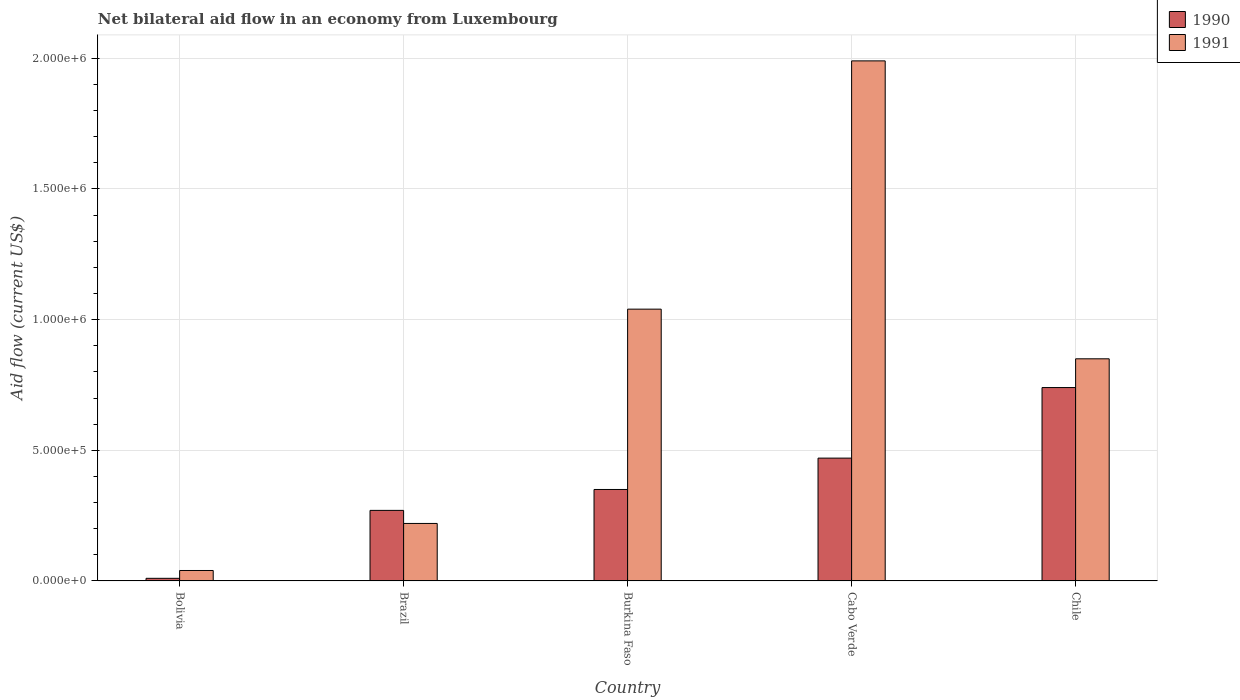How many different coloured bars are there?
Give a very brief answer. 2. How many bars are there on the 5th tick from the left?
Your answer should be compact. 2. In how many cases, is the number of bars for a given country not equal to the number of legend labels?
Your answer should be very brief. 0. What is the net bilateral aid flow in 1991 in Cabo Verde?
Offer a very short reply. 1.99e+06. Across all countries, what is the maximum net bilateral aid flow in 1991?
Offer a very short reply. 1.99e+06. In which country was the net bilateral aid flow in 1991 minimum?
Keep it short and to the point. Bolivia. What is the total net bilateral aid flow in 1991 in the graph?
Provide a succinct answer. 4.14e+06. What is the difference between the net bilateral aid flow in 1991 in Burkina Faso and the net bilateral aid flow in 1990 in Brazil?
Provide a short and direct response. 7.70e+05. What is the average net bilateral aid flow in 1991 per country?
Make the answer very short. 8.28e+05. What is the difference between the net bilateral aid flow of/in 1990 and net bilateral aid flow of/in 1991 in Bolivia?
Your answer should be compact. -3.00e+04. In how many countries, is the net bilateral aid flow in 1991 greater than 100000 US$?
Provide a short and direct response. 4. What is the ratio of the net bilateral aid flow in 1991 in Bolivia to that in Brazil?
Offer a terse response. 0.18. Is the difference between the net bilateral aid flow in 1990 in Bolivia and Cabo Verde greater than the difference between the net bilateral aid flow in 1991 in Bolivia and Cabo Verde?
Offer a very short reply. Yes. What is the difference between the highest and the second highest net bilateral aid flow in 1991?
Your answer should be compact. 1.14e+06. What is the difference between the highest and the lowest net bilateral aid flow in 1990?
Provide a short and direct response. 7.30e+05. Are all the bars in the graph horizontal?
Keep it short and to the point. No. How many countries are there in the graph?
Ensure brevity in your answer.  5. Are the values on the major ticks of Y-axis written in scientific E-notation?
Provide a succinct answer. Yes. Where does the legend appear in the graph?
Offer a terse response. Top right. How are the legend labels stacked?
Offer a very short reply. Vertical. What is the title of the graph?
Make the answer very short. Net bilateral aid flow in an economy from Luxembourg. What is the Aid flow (current US$) in 1990 in Bolivia?
Your answer should be compact. 10000. What is the Aid flow (current US$) in 1991 in Bolivia?
Provide a short and direct response. 4.00e+04. What is the Aid flow (current US$) in 1990 in Burkina Faso?
Offer a terse response. 3.50e+05. What is the Aid flow (current US$) of 1991 in Burkina Faso?
Ensure brevity in your answer.  1.04e+06. What is the Aid flow (current US$) of 1991 in Cabo Verde?
Make the answer very short. 1.99e+06. What is the Aid flow (current US$) in 1990 in Chile?
Your response must be concise. 7.40e+05. What is the Aid flow (current US$) of 1991 in Chile?
Provide a succinct answer. 8.50e+05. Across all countries, what is the maximum Aid flow (current US$) in 1990?
Give a very brief answer. 7.40e+05. Across all countries, what is the maximum Aid flow (current US$) of 1991?
Make the answer very short. 1.99e+06. Across all countries, what is the minimum Aid flow (current US$) in 1990?
Provide a succinct answer. 10000. What is the total Aid flow (current US$) of 1990 in the graph?
Your answer should be compact. 1.84e+06. What is the total Aid flow (current US$) in 1991 in the graph?
Your answer should be compact. 4.14e+06. What is the difference between the Aid flow (current US$) of 1990 in Bolivia and that in Cabo Verde?
Offer a terse response. -4.60e+05. What is the difference between the Aid flow (current US$) of 1991 in Bolivia and that in Cabo Verde?
Make the answer very short. -1.95e+06. What is the difference between the Aid flow (current US$) in 1990 in Bolivia and that in Chile?
Your answer should be very brief. -7.30e+05. What is the difference between the Aid flow (current US$) in 1991 in Bolivia and that in Chile?
Make the answer very short. -8.10e+05. What is the difference between the Aid flow (current US$) of 1991 in Brazil and that in Burkina Faso?
Give a very brief answer. -8.20e+05. What is the difference between the Aid flow (current US$) of 1990 in Brazil and that in Cabo Verde?
Offer a terse response. -2.00e+05. What is the difference between the Aid flow (current US$) in 1991 in Brazil and that in Cabo Verde?
Provide a succinct answer. -1.77e+06. What is the difference between the Aid flow (current US$) in 1990 in Brazil and that in Chile?
Give a very brief answer. -4.70e+05. What is the difference between the Aid flow (current US$) in 1991 in Brazil and that in Chile?
Ensure brevity in your answer.  -6.30e+05. What is the difference between the Aid flow (current US$) in 1990 in Burkina Faso and that in Cabo Verde?
Your answer should be compact. -1.20e+05. What is the difference between the Aid flow (current US$) of 1991 in Burkina Faso and that in Cabo Verde?
Provide a succinct answer. -9.50e+05. What is the difference between the Aid flow (current US$) of 1990 in Burkina Faso and that in Chile?
Your answer should be very brief. -3.90e+05. What is the difference between the Aid flow (current US$) in 1991 in Cabo Verde and that in Chile?
Your response must be concise. 1.14e+06. What is the difference between the Aid flow (current US$) in 1990 in Bolivia and the Aid flow (current US$) in 1991 in Brazil?
Keep it short and to the point. -2.10e+05. What is the difference between the Aid flow (current US$) of 1990 in Bolivia and the Aid flow (current US$) of 1991 in Burkina Faso?
Make the answer very short. -1.03e+06. What is the difference between the Aid flow (current US$) in 1990 in Bolivia and the Aid flow (current US$) in 1991 in Cabo Verde?
Offer a terse response. -1.98e+06. What is the difference between the Aid flow (current US$) of 1990 in Bolivia and the Aid flow (current US$) of 1991 in Chile?
Your response must be concise. -8.40e+05. What is the difference between the Aid flow (current US$) of 1990 in Brazil and the Aid flow (current US$) of 1991 in Burkina Faso?
Offer a terse response. -7.70e+05. What is the difference between the Aid flow (current US$) of 1990 in Brazil and the Aid flow (current US$) of 1991 in Cabo Verde?
Give a very brief answer. -1.72e+06. What is the difference between the Aid flow (current US$) of 1990 in Brazil and the Aid flow (current US$) of 1991 in Chile?
Your response must be concise. -5.80e+05. What is the difference between the Aid flow (current US$) of 1990 in Burkina Faso and the Aid flow (current US$) of 1991 in Cabo Verde?
Offer a terse response. -1.64e+06. What is the difference between the Aid flow (current US$) in 1990 in Burkina Faso and the Aid flow (current US$) in 1991 in Chile?
Ensure brevity in your answer.  -5.00e+05. What is the difference between the Aid flow (current US$) of 1990 in Cabo Verde and the Aid flow (current US$) of 1991 in Chile?
Give a very brief answer. -3.80e+05. What is the average Aid flow (current US$) of 1990 per country?
Offer a very short reply. 3.68e+05. What is the average Aid flow (current US$) in 1991 per country?
Your answer should be compact. 8.28e+05. What is the difference between the Aid flow (current US$) of 1990 and Aid flow (current US$) of 1991 in Burkina Faso?
Provide a succinct answer. -6.90e+05. What is the difference between the Aid flow (current US$) in 1990 and Aid flow (current US$) in 1991 in Cabo Verde?
Provide a short and direct response. -1.52e+06. What is the difference between the Aid flow (current US$) in 1990 and Aid flow (current US$) in 1991 in Chile?
Your answer should be very brief. -1.10e+05. What is the ratio of the Aid flow (current US$) in 1990 in Bolivia to that in Brazil?
Provide a succinct answer. 0.04. What is the ratio of the Aid flow (current US$) of 1991 in Bolivia to that in Brazil?
Your response must be concise. 0.18. What is the ratio of the Aid flow (current US$) of 1990 in Bolivia to that in Burkina Faso?
Make the answer very short. 0.03. What is the ratio of the Aid flow (current US$) of 1991 in Bolivia to that in Burkina Faso?
Provide a succinct answer. 0.04. What is the ratio of the Aid flow (current US$) in 1990 in Bolivia to that in Cabo Verde?
Your response must be concise. 0.02. What is the ratio of the Aid flow (current US$) of 1991 in Bolivia to that in Cabo Verde?
Offer a very short reply. 0.02. What is the ratio of the Aid flow (current US$) in 1990 in Bolivia to that in Chile?
Make the answer very short. 0.01. What is the ratio of the Aid flow (current US$) of 1991 in Bolivia to that in Chile?
Give a very brief answer. 0.05. What is the ratio of the Aid flow (current US$) in 1990 in Brazil to that in Burkina Faso?
Provide a succinct answer. 0.77. What is the ratio of the Aid flow (current US$) of 1991 in Brazil to that in Burkina Faso?
Provide a short and direct response. 0.21. What is the ratio of the Aid flow (current US$) in 1990 in Brazil to that in Cabo Verde?
Offer a very short reply. 0.57. What is the ratio of the Aid flow (current US$) in 1991 in Brazil to that in Cabo Verde?
Give a very brief answer. 0.11. What is the ratio of the Aid flow (current US$) in 1990 in Brazil to that in Chile?
Provide a short and direct response. 0.36. What is the ratio of the Aid flow (current US$) in 1991 in Brazil to that in Chile?
Offer a terse response. 0.26. What is the ratio of the Aid flow (current US$) in 1990 in Burkina Faso to that in Cabo Verde?
Your answer should be compact. 0.74. What is the ratio of the Aid flow (current US$) of 1991 in Burkina Faso to that in Cabo Verde?
Give a very brief answer. 0.52. What is the ratio of the Aid flow (current US$) of 1990 in Burkina Faso to that in Chile?
Provide a short and direct response. 0.47. What is the ratio of the Aid flow (current US$) of 1991 in Burkina Faso to that in Chile?
Make the answer very short. 1.22. What is the ratio of the Aid flow (current US$) in 1990 in Cabo Verde to that in Chile?
Offer a very short reply. 0.64. What is the ratio of the Aid flow (current US$) in 1991 in Cabo Verde to that in Chile?
Offer a terse response. 2.34. What is the difference between the highest and the second highest Aid flow (current US$) of 1991?
Offer a very short reply. 9.50e+05. What is the difference between the highest and the lowest Aid flow (current US$) of 1990?
Ensure brevity in your answer.  7.30e+05. What is the difference between the highest and the lowest Aid flow (current US$) in 1991?
Ensure brevity in your answer.  1.95e+06. 